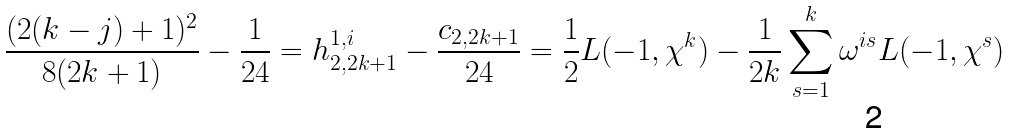<formula> <loc_0><loc_0><loc_500><loc_500>\frac { ( 2 ( k - j ) + 1 ) ^ { 2 } } { 8 ( 2 k + 1 ) } - \frac { 1 } { 2 4 } = h _ { 2 , 2 k + 1 } ^ { 1 , i } - \frac { c _ { 2 , 2 k + 1 } } { 2 4 } = \frac { 1 } { 2 } L ( - 1 , \chi ^ { k } ) - \frac { 1 } { 2 k } \sum _ { s = 1 } ^ { k } \omega ^ { i s } L ( - 1 , \chi ^ { s } )</formula> 